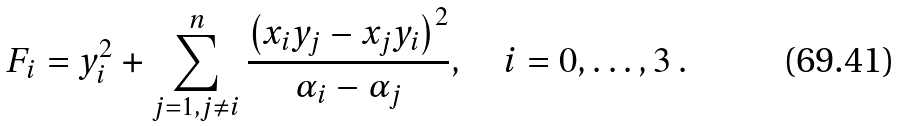<formula> <loc_0><loc_0><loc_500><loc_500>F _ { i } = y _ { i } ^ { 2 } + \sum _ { j = 1 , j \ne i } ^ { n } \frac { \left ( x _ { i } y _ { j } - x _ { j } y _ { i } \right ) ^ { 2 } } { \alpha _ { i } - \alpha _ { j } } , \quad i = 0 , \dots , 3 \, .</formula> 